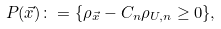<formula> <loc_0><loc_0><loc_500><loc_500>P ( \vec { x } ) \colon = \{ \rho _ { \vec { x } } - C _ { n } \rho _ { U , n } \geq 0 \} ,</formula> 